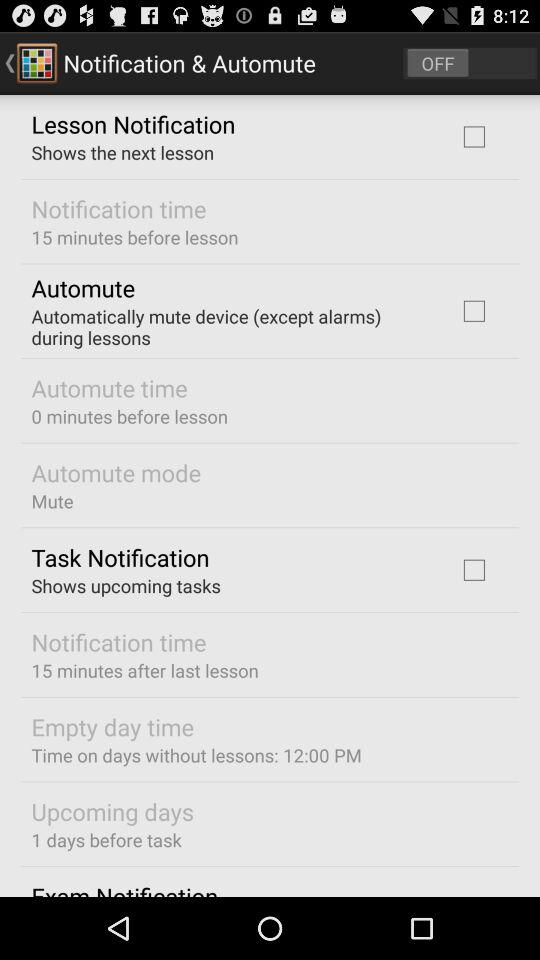What is the status of "Notification & Automute"? "Notification & Automute" is turned off. 